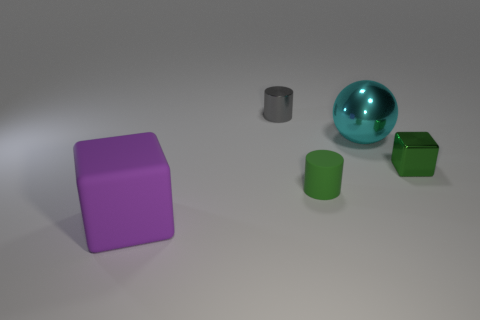Add 3 yellow matte spheres. How many objects exist? 8 Subtract all big blue metallic blocks. Subtract all tiny gray metal cylinders. How many objects are left? 4 Add 4 green matte cylinders. How many green matte cylinders are left? 5 Add 3 gray matte cylinders. How many gray matte cylinders exist? 3 Subtract 0 red cylinders. How many objects are left? 5 Subtract all spheres. How many objects are left? 4 